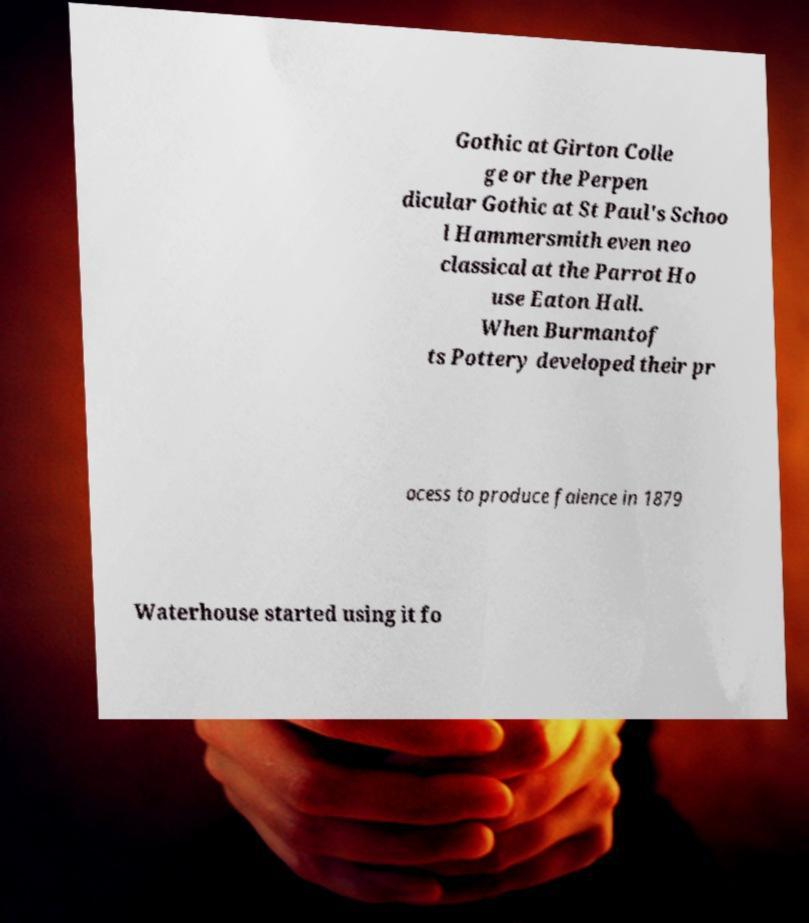There's text embedded in this image that I need extracted. Can you transcribe it verbatim? Gothic at Girton Colle ge or the Perpen dicular Gothic at St Paul's Schoo l Hammersmith even neo classical at the Parrot Ho use Eaton Hall. When Burmantof ts Pottery developed their pr ocess to produce faience in 1879 Waterhouse started using it fo 